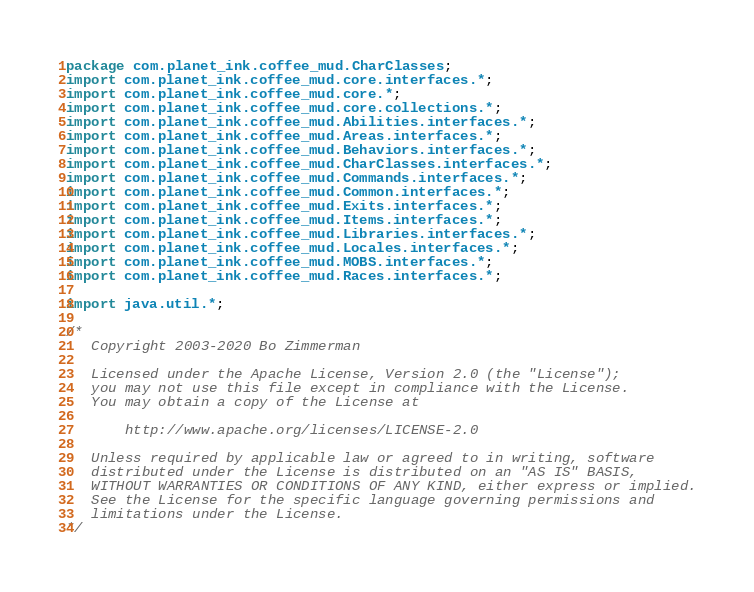<code> <loc_0><loc_0><loc_500><loc_500><_Java_>package com.planet_ink.coffee_mud.CharClasses;
import com.planet_ink.coffee_mud.core.interfaces.*;
import com.planet_ink.coffee_mud.core.*;
import com.planet_ink.coffee_mud.core.collections.*;
import com.planet_ink.coffee_mud.Abilities.interfaces.*;
import com.planet_ink.coffee_mud.Areas.interfaces.*;
import com.planet_ink.coffee_mud.Behaviors.interfaces.*;
import com.planet_ink.coffee_mud.CharClasses.interfaces.*;
import com.planet_ink.coffee_mud.Commands.interfaces.*;
import com.planet_ink.coffee_mud.Common.interfaces.*;
import com.planet_ink.coffee_mud.Exits.interfaces.*;
import com.planet_ink.coffee_mud.Items.interfaces.*;
import com.planet_ink.coffee_mud.Libraries.interfaces.*;
import com.planet_ink.coffee_mud.Locales.interfaces.*;
import com.planet_ink.coffee_mud.MOBS.interfaces.*;
import com.planet_ink.coffee_mud.Races.interfaces.*;

import java.util.*;

/*
   Copyright 2003-2020 Bo Zimmerman

   Licensed under the Apache License, Version 2.0 (the "License");
   you may not use this file except in compliance with the License.
   You may obtain a copy of the License at

	   http://www.apache.org/licenses/LICENSE-2.0

   Unless required by applicable law or agreed to in writing, software
   distributed under the License is distributed on an "AS IS" BASIS,
   WITHOUT WARRANTIES OR CONDITIONS OF ANY KIND, either express or implied.
   See the License for the specific language governing permissions and
   limitations under the License.
*/</code> 